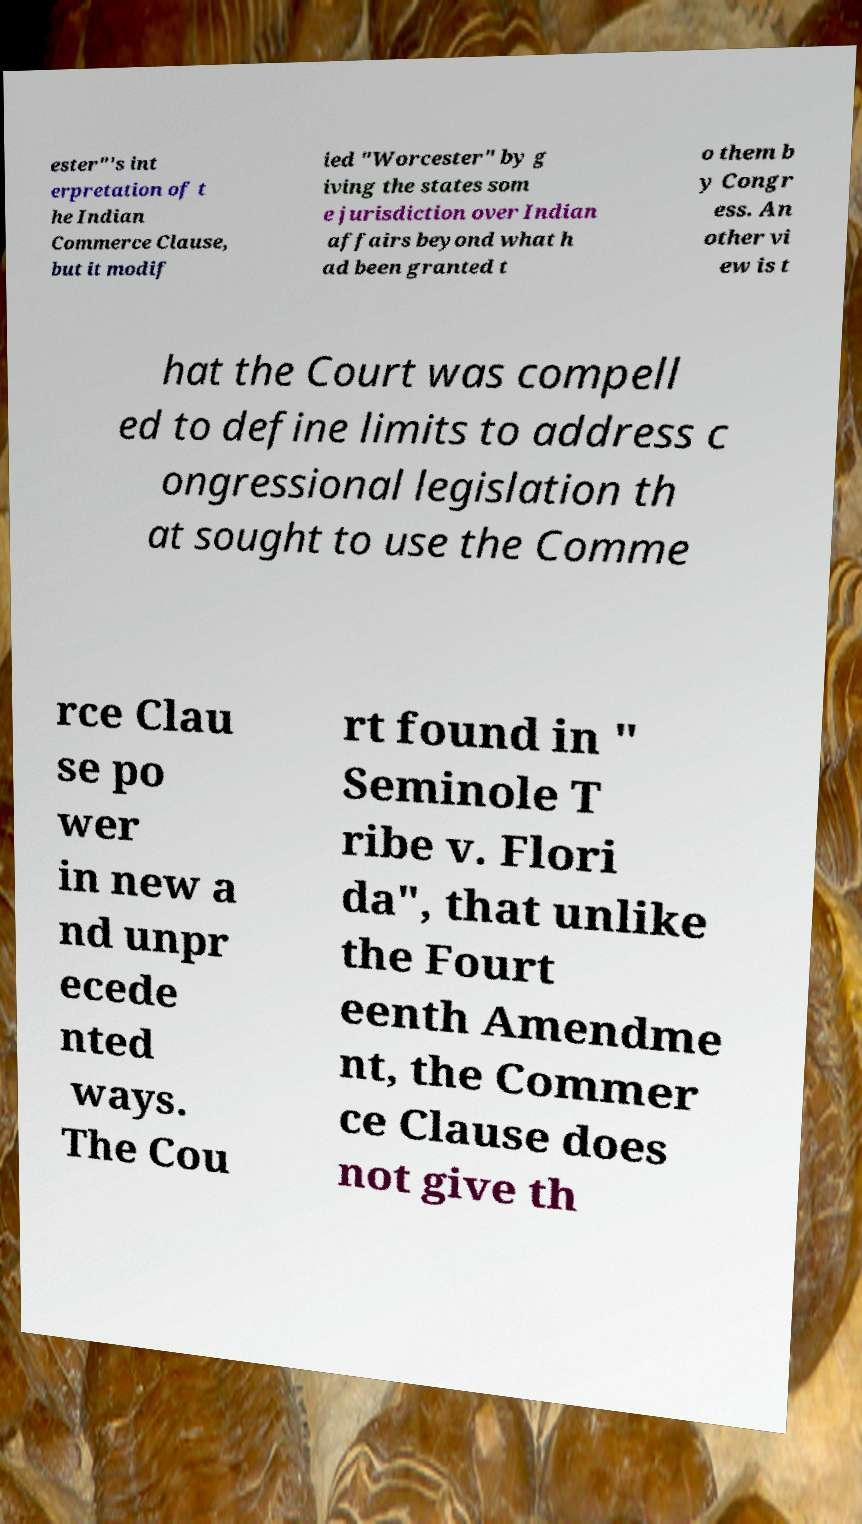Can you accurately transcribe the text from the provided image for me? ester"'s int erpretation of t he Indian Commerce Clause, but it modif ied "Worcester" by g iving the states som e jurisdiction over Indian affairs beyond what h ad been granted t o them b y Congr ess. An other vi ew is t hat the Court was compell ed to define limits to address c ongressional legislation th at sought to use the Comme rce Clau se po wer in new a nd unpr ecede nted ways. The Cou rt found in " Seminole T ribe v. Flori da", that unlike the Fourt eenth Amendme nt, the Commer ce Clause does not give th 